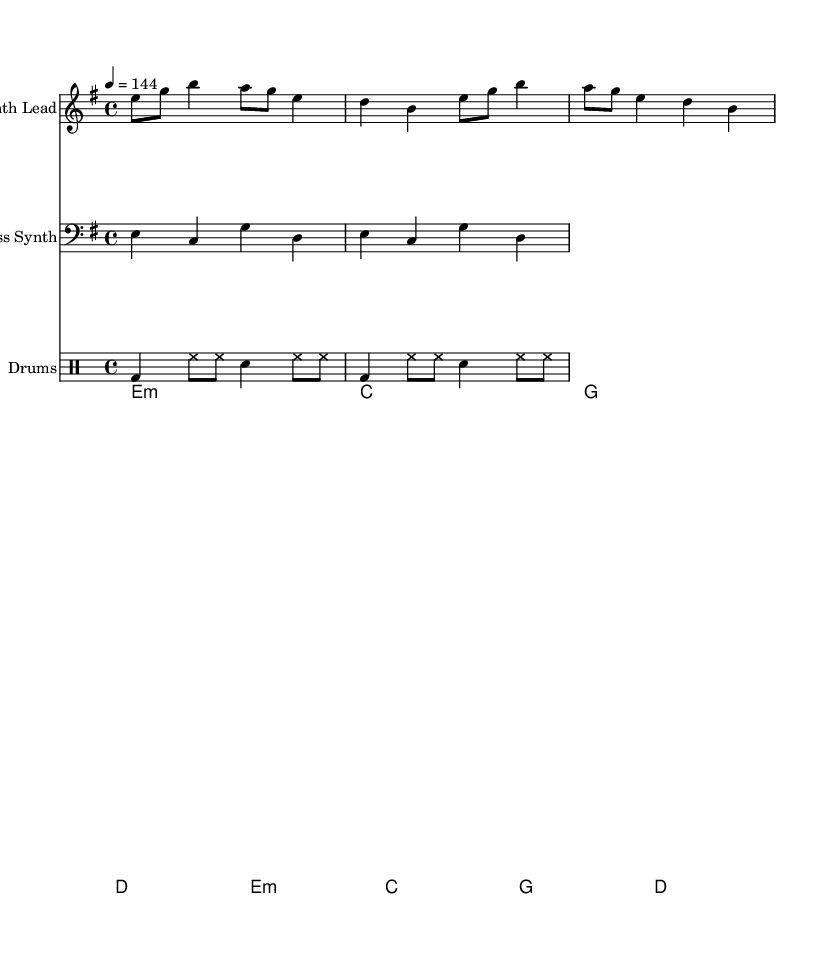What is the key signature of this music? The music is in E minor, which has one sharp (F#) in its key signature. The presence of one sharp indicates that E minor is the key.
Answer: E minor What is the time signature of the piece? The time signature is 4/4, indicated at the beginning of the score. This means there are four beats in each measure.
Answer: 4/4 What is the tempo marking for the piece? The tempo marking is indicated as 4 = 144, meaning that there are 144 beats per minute, with each beat corresponding to a quarter note.
Answer: 144 How many measures are in the synth lead part? By counting the number of measures in the synth lead part, it can be determined that there are four measures. Each measure contains the same rhythmic pattern, repeating twice.
Answer: 4 What is the rhythmic pattern for the drums? The drum pattern consists of a bass drum on the first beat, followed by hi-hat notes and a snare on the third beat, creating a driving rhythm typical for action sports.
Answer: Bass and hi-hat Does this music follow a repetitive structure? Yes, the music follows a repetitive structure with both the synth lead and the bass synth repeating their patterns over the designated measures, enhancing the driving beat.
Answer: Yes 